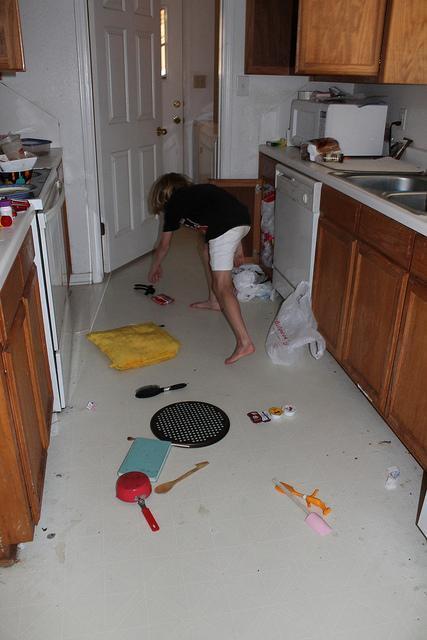How many chairs are on the right side of the tree?
Give a very brief answer. 0. 